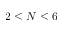<formula> <loc_0><loc_0><loc_500><loc_500>2 \leq N \leq 6</formula> 